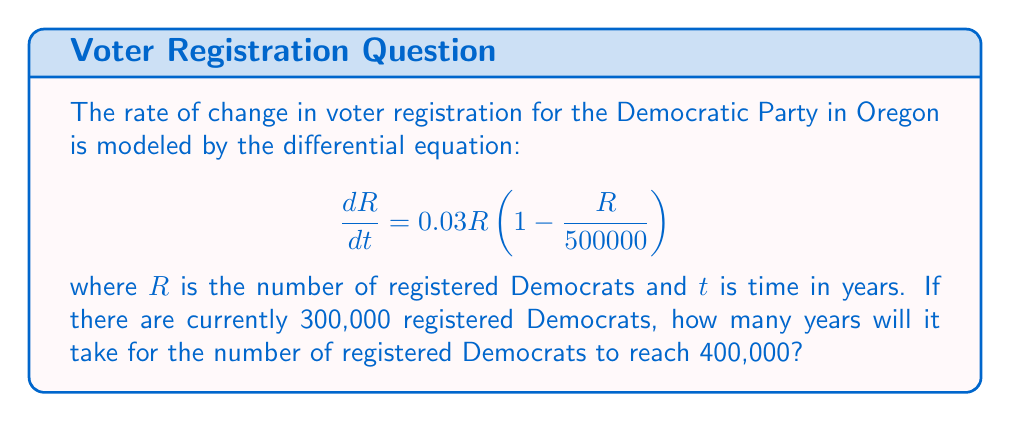Give your solution to this math problem. To solve this problem, we need to use separation of variables and integration:

1) Rearrange the differential equation:
   $$\frac{dR}{R(1 - \frac{R}{500000})} = 0.03dt$$

2) Integrate both sides:
   $$\int_{300000}^{400000} \frac{dR}{R(1 - \frac{R}{500000})} = \int_0^T 0.03dt$$

   where $T$ is the time we're solving for.

3) The left side can be integrated using partial fractions:
   $$[\ln|R| - \ln|500000-R|]_{300000}^{400000} = 0.03T$$

4) Evaluate the left side:
   $$(\ln(400000) - \ln(100000)) - (\ln(300000) - \ln(200000)) = 0.03T$$

5) Simplify:
   $$\ln(\frac{4}{3}) + \ln(2) = 0.03T$$

6) Solve for $T$:
   $$T = \frac{\ln(\frac{8}{3})}{0.03} \approx 32.99$$

Therefore, it will take approximately 33 years for the number of registered Democrats to reach 400,000.
Answer: It will take approximately 33 years for the number of registered Democrats in Oregon to increase from 300,000 to 400,000. 